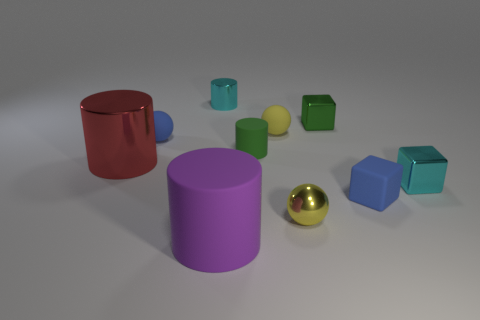Subtract all tiny metallic blocks. How many blocks are left? 1 Subtract all red cylinders. How many cylinders are left? 3 Subtract all cylinders. How many objects are left? 6 Subtract 2 spheres. How many spheres are left? 1 Subtract all gray spheres. Subtract all yellow cylinders. How many spheres are left? 3 Subtract all brown cylinders. How many blue blocks are left? 1 Subtract all blue rubber blocks. Subtract all tiny red cylinders. How many objects are left? 9 Add 1 green matte things. How many green matte things are left? 2 Add 4 rubber objects. How many rubber objects exist? 9 Subtract 0 gray balls. How many objects are left? 10 